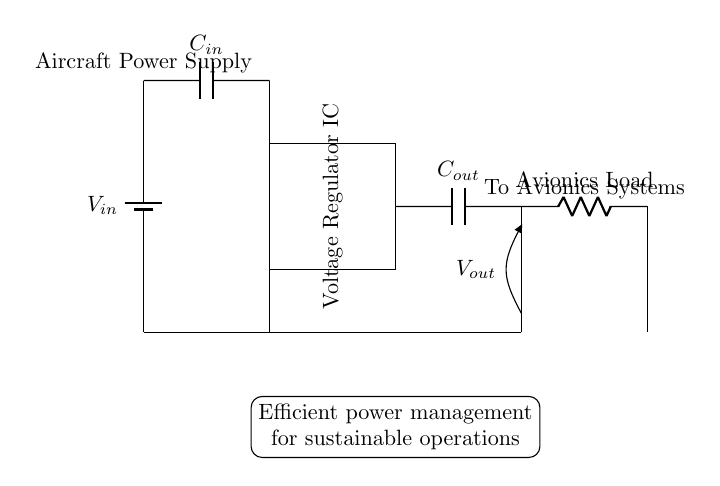What type of capacitor is used at the input? The circuit shows a capacitor labeled as C_in connected to the input voltage. According to common practices, input capacitors are often used to stabilize the voltage supply and filter noise. Therefore, it can be identified as an input capacitor.
Answer: Input capacitor What does the voltage regulator IC do? The voltage regulator IC is designed to maintain a constant output voltage level despite variations in input voltage or load conditions. This is essential for providing stable power to sensitive avionics systems.
Answer: Regulates voltage What is the purpose of the output capacitor? The output capacitor, labeled C_out, is connected at the output of the voltage regulator. Its primary role is to stabilize the output voltage and filter any noise present in the supply that can affect the operation of the avionics systems.
Answer: Stabilizes output What is the symbol for the load connected in this circuit? The element representing the load in the circuit is depicted as a resistor labeled "Avionics Load." Resistors are standard symbols for loads in circuit diagrams. This represents the power demand by the avionics systems.
Answer: Resistor How does this circuit contribute to sustainability? The circuit is labeled with a note indicating "Efficient power management for sustainable operations." The voltage regulator ensures efficient power usage by maintaining optimal voltage levels and reducing waste. Efficient power usage translates into lower energy consumption and environmental impact.
Answer: Efficient power management 